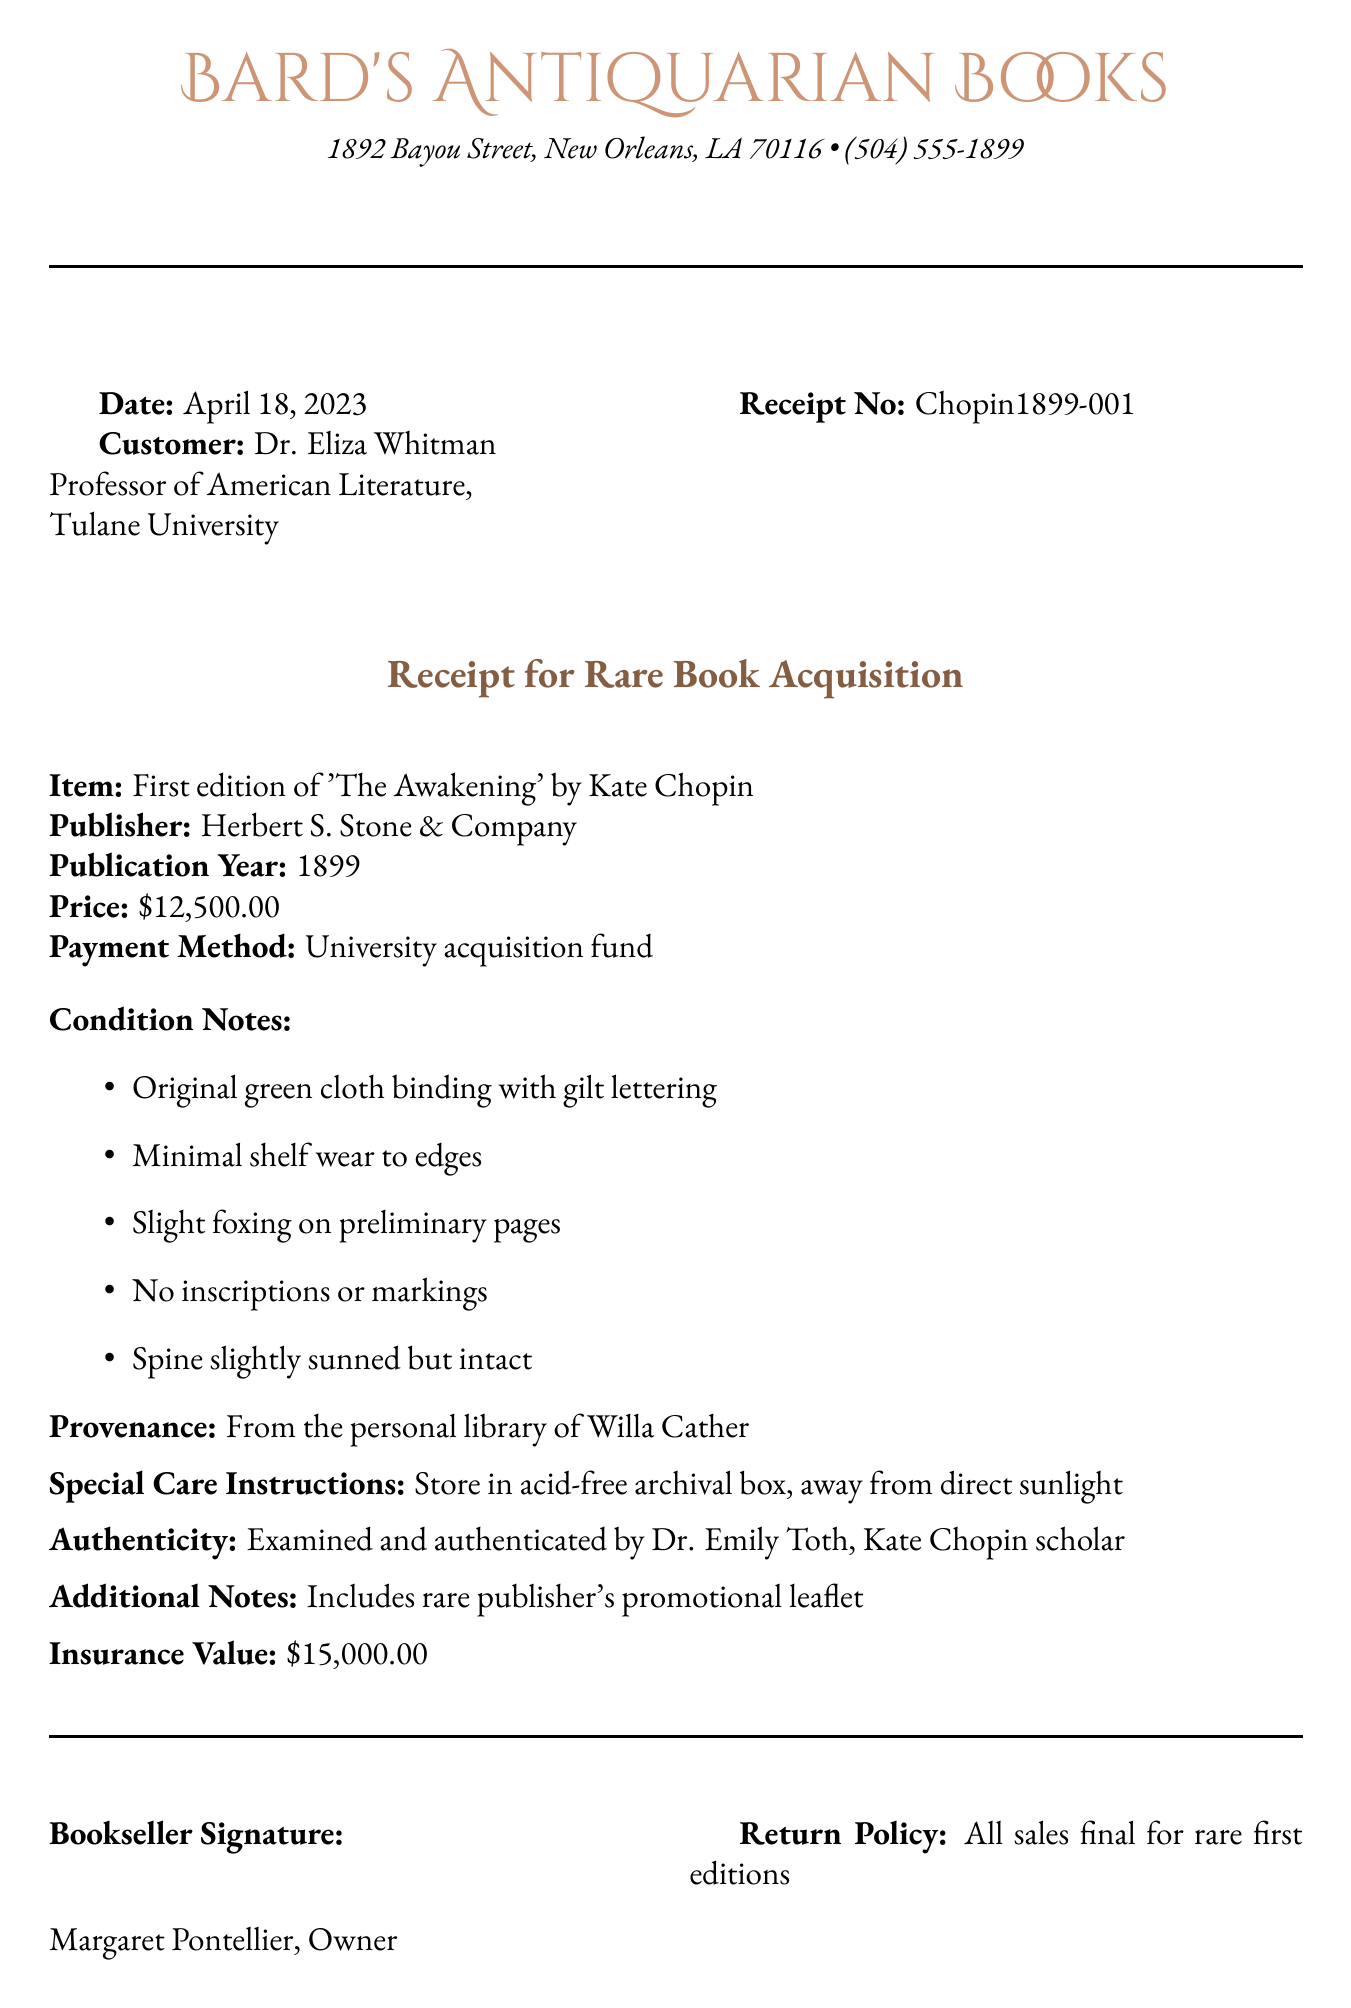What is the name of the bookstore? The bookstore's name is provided at the top of the document.
Answer: Bard's Antiquarian Books Who is the customer of this transaction? The customer's name and title are listed in the document.
Answer: Dr. Eliza Whitman What is the publication year of the book? The publication year is specified in the item description section.
Answer: 1899 What is the price of the book? The price is explicitly stated in the receipt.
Answer: $12,500.00 What is the provenance of the book? The provenance reveals the previous owner's details noted in the document.
Answer: From the personal library of Willa Cather What is the insurance value of the book? The document includes an insurance value, indicating its worth for coverage purposes.
Answer: $15,000.00 What condition issue is noted on the preliminary pages? The document lists specific condition notes that include issues with foxing.
Answer: Slight foxing What should the book be stored in? Special care instructions indicate how the book should be stored.
Answer: Acid-free archival box What is the authenticity verification for the book? The document indicates who examined and authenticated the book as a scholar.
Answer: Examined and authenticated by Dr. Emily Toth What is the return policy for the rare first edition? The return policy is clearly stated in the document.
Answer: All sales final for rare first editions 